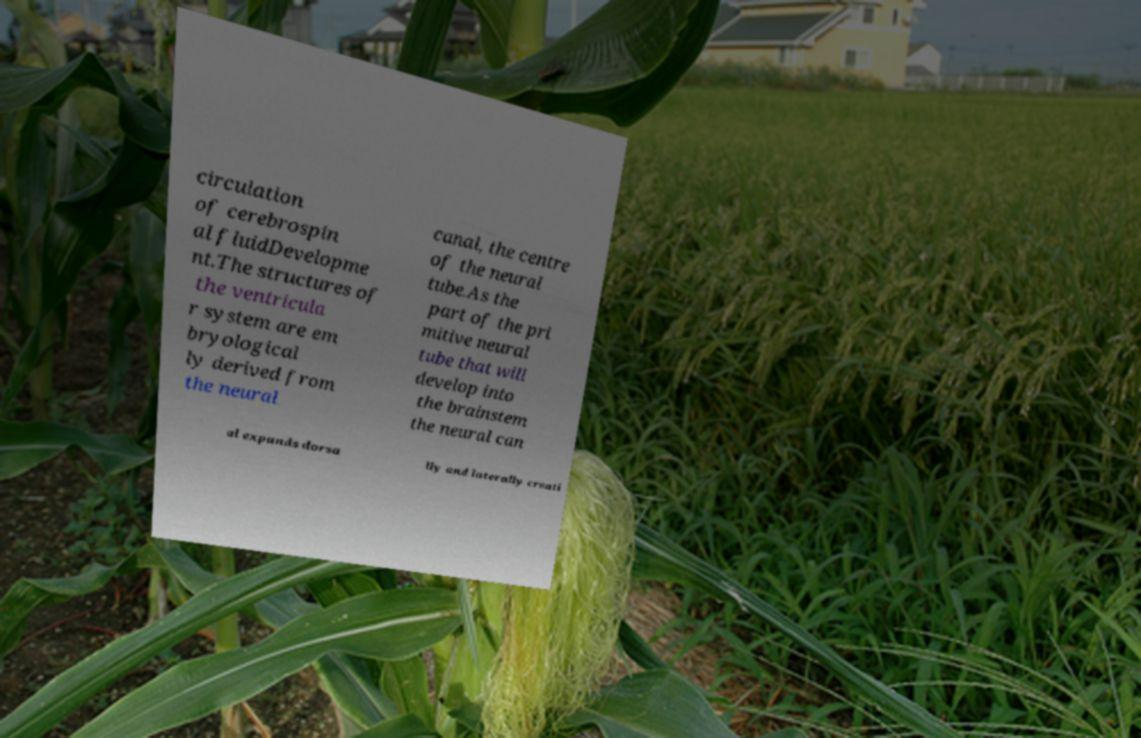Could you assist in decoding the text presented in this image and type it out clearly? circulation of cerebrospin al fluidDevelopme nt.The structures of the ventricula r system are em bryological ly derived from the neural canal, the centre of the neural tube.As the part of the pri mitive neural tube that will develop into the brainstem the neural can al expands dorsa lly and laterally creati 